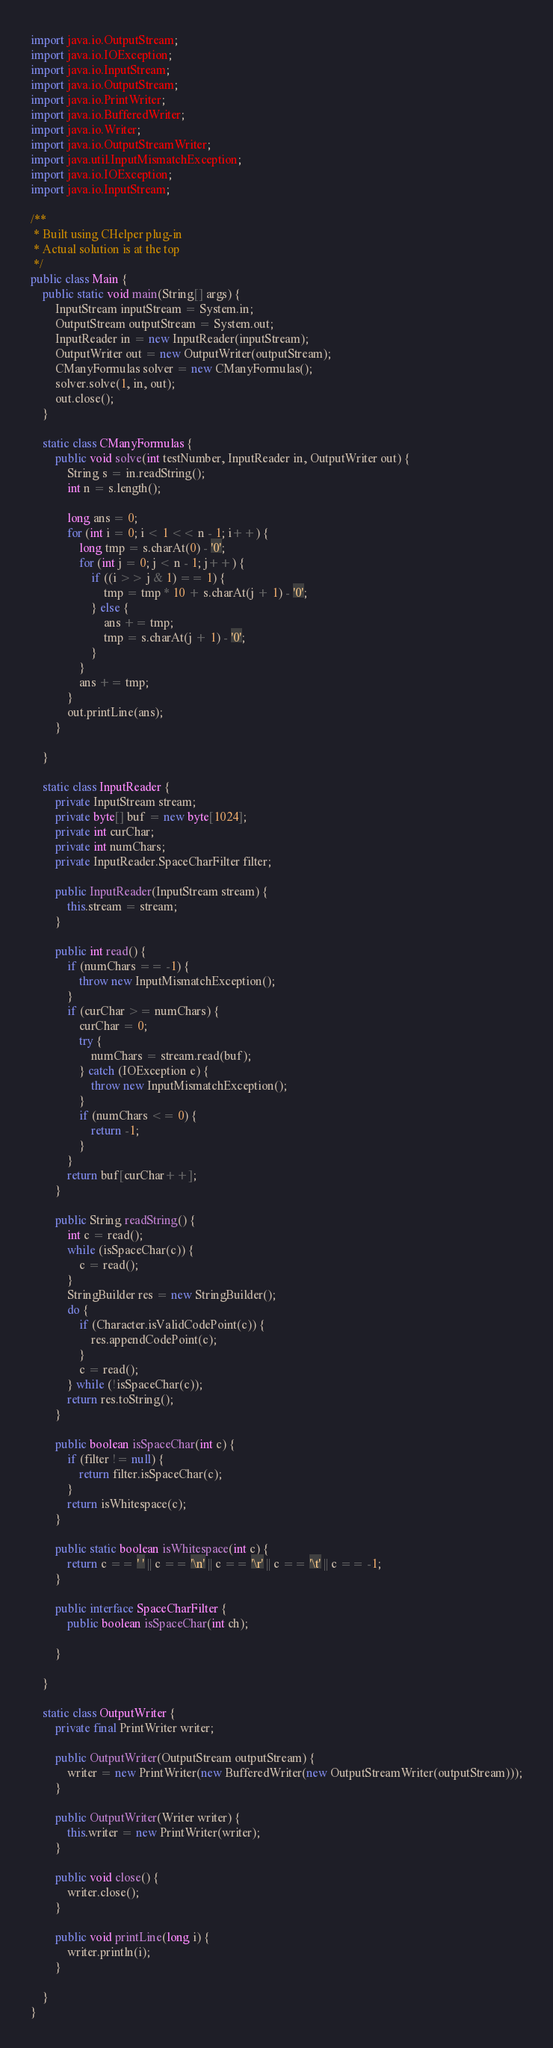Convert code to text. <code><loc_0><loc_0><loc_500><loc_500><_Java_>import java.io.OutputStream;
import java.io.IOException;
import java.io.InputStream;
import java.io.OutputStream;
import java.io.PrintWriter;
import java.io.BufferedWriter;
import java.io.Writer;
import java.io.OutputStreamWriter;
import java.util.InputMismatchException;
import java.io.IOException;
import java.io.InputStream;

/**
 * Built using CHelper plug-in
 * Actual solution is at the top
 */
public class Main {
    public static void main(String[] args) {
        InputStream inputStream = System.in;
        OutputStream outputStream = System.out;
        InputReader in = new InputReader(inputStream);
        OutputWriter out = new OutputWriter(outputStream);
        CManyFormulas solver = new CManyFormulas();
        solver.solve(1, in, out);
        out.close();
    }

    static class CManyFormulas {
        public void solve(int testNumber, InputReader in, OutputWriter out) {
            String s = in.readString();
            int n = s.length();

            long ans = 0;
            for (int i = 0; i < 1 << n - 1; i++) {
                long tmp = s.charAt(0) - '0';
                for (int j = 0; j < n - 1; j++) {
                    if ((i >> j & 1) == 1) {
                        tmp = tmp * 10 + s.charAt(j + 1) - '0';
                    } else {
                        ans += tmp;
                        tmp = s.charAt(j + 1) - '0';
                    }
                }
                ans += tmp;
            }
            out.printLine(ans);
        }

    }

    static class InputReader {
        private InputStream stream;
        private byte[] buf = new byte[1024];
        private int curChar;
        private int numChars;
        private InputReader.SpaceCharFilter filter;

        public InputReader(InputStream stream) {
            this.stream = stream;
        }

        public int read() {
            if (numChars == -1) {
                throw new InputMismatchException();
            }
            if (curChar >= numChars) {
                curChar = 0;
                try {
                    numChars = stream.read(buf);
                } catch (IOException e) {
                    throw new InputMismatchException();
                }
                if (numChars <= 0) {
                    return -1;
                }
            }
            return buf[curChar++];
        }

        public String readString() {
            int c = read();
            while (isSpaceChar(c)) {
                c = read();
            }
            StringBuilder res = new StringBuilder();
            do {
                if (Character.isValidCodePoint(c)) {
                    res.appendCodePoint(c);
                }
                c = read();
            } while (!isSpaceChar(c));
            return res.toString();
        }

        public boolean isSpaceChar(int c) {
            if (filter != null) {
                return filter.isSpaceChar(c);
            }
            return isWhitespace(c);
        }

        public static boolean isWhitespace(int c) {
            return c == ' ' || c == '\n' || c == '\r' || c == '\t' || c == -1;
        }

        public interface SpaceCharFilter {
            public boolean isSpaceChar(int ch);

        }

    }

    static class OutputWriter {
        private final PrintWriter writer;

        public OutputWriter(OutputStream outputStream) {
            writer = new PrintWriter(new BufferedWriter(new OutputStreamWriter(outputStream)));
        }

        public OutputWriter(Writer writer) {
            this.writer = new PrintWriter(writer);
        }

        public void close() {
            writer.close();
        }

        public void printLine(long i) {
            writer.println(i);
        }

    }
}

</code> 